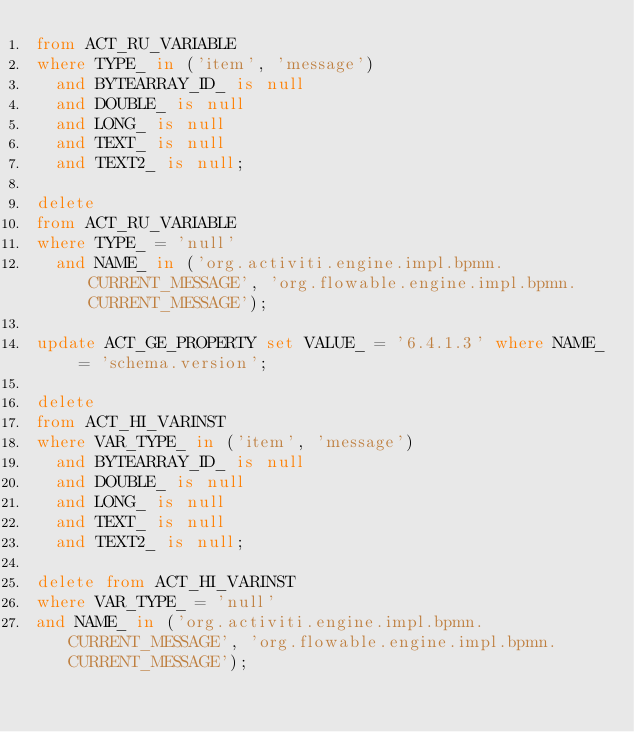Convert code to text. <code><loc_0><loc_0><loc_500><loc_500><_SQL_>from ACT_RU_VARIABLE
where TYPE_ in ('item', 'message')
  and BYTEARRAY_ID_ is null
  and DOUBLE_ is null
  and LONG_ is null
  and TEXT_ is null
  and TEXT2_ is null;

delete
from ACT_RU_VARIABLE
where TYPE_ = 'null'
  and NAME_ in ('org.activiti.engine.impl.bpmn.CURRENT_MESSAGE', 'org.flowable.engine.impl.bpmn.CURRENT_MESSAGE');

update ACT_GE_PROPERTY set VALUE_ = '6.4.1.3' where NAME_ = 'schema.version';

delete
from ACT_HI_VARINST
where VAR_TYPE_ in ('item', 'message')
  and BYTEARRAY_ID_ is null
  and DOUBLE_ is null
  and LONG_ is null
  and TEXT_ is null
  and TEXT2_ is null;

delete from ACT_HI_VARINST
where VAR_TYPE_ = 'null'
and NAME_ in ('org.activiti.engine.impl.bpmn.CURRENT_MESSAGE', 'org.flowable.engine.impl.bpmn.CURRENT_MESSAGE');
</code> 